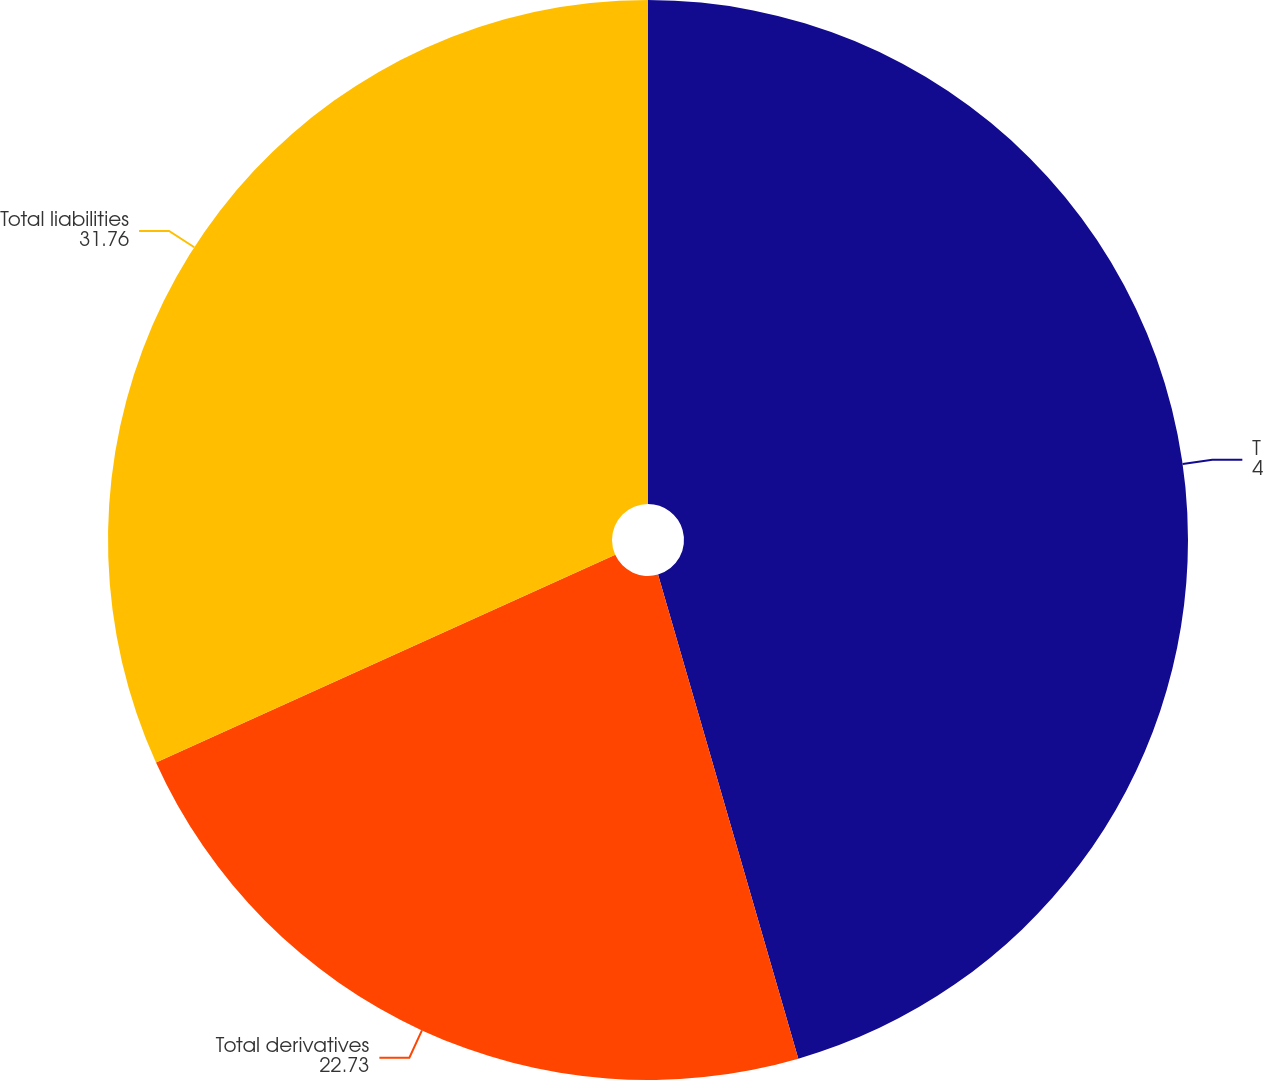Convert chart. <chart><loc_0><loc_0><loc_500><loc_500><pie_chart><fcel>Total assets<fcel>Total derivatives<fcel>Total liabilities<nl><fcel>45.51%<fcel>22.73%<fcel>31.76%<nl></chart> 